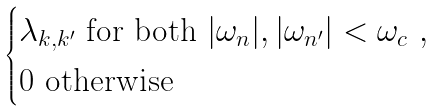Convert formula to latex. <formula><loc_0><loc_0><loc_500><loc_500>\begin{cases} \lambda _ { { k } , { k } ^ { \prime } } \ \text {for both} \ | \omega _ { n } | , | \omega _ { n ^ { \prime } } | < \omega _ { c } \ , \\ 0 \ \text {otherwise} \end{cases}</formula> 